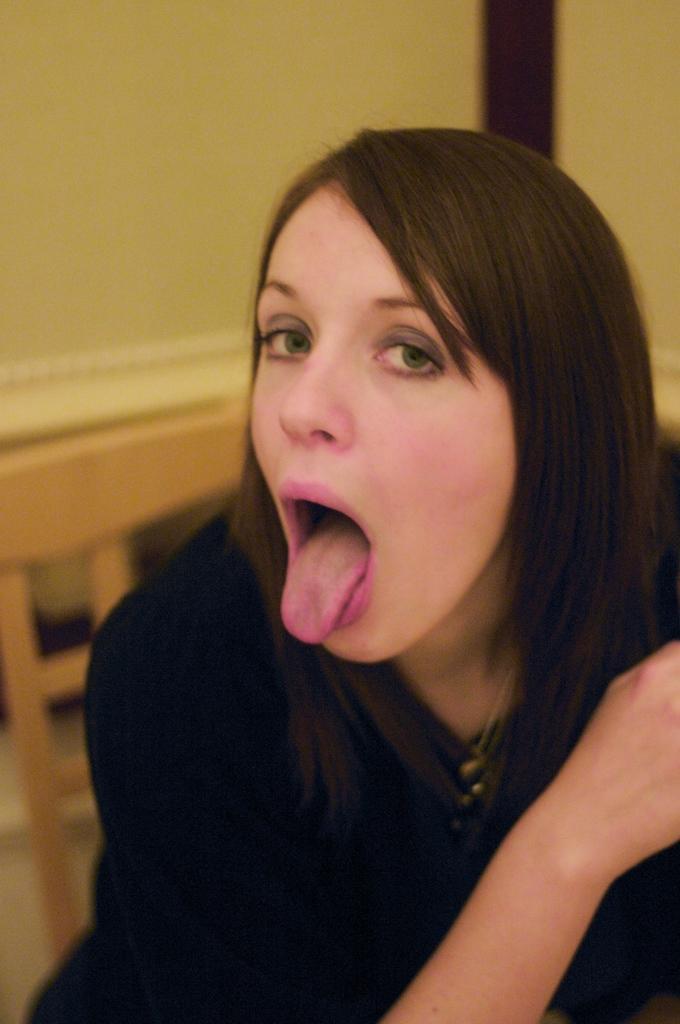Please provide a concise description of this image. In this image we can see a lady, she is wearing black color dress. Behind yellow color wall is there. 